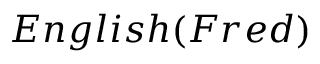Convert formula to latex. <formula><loc_0><loc_0><loc_500><loc_500>E n g l i s h ( F r e d )</formula> 